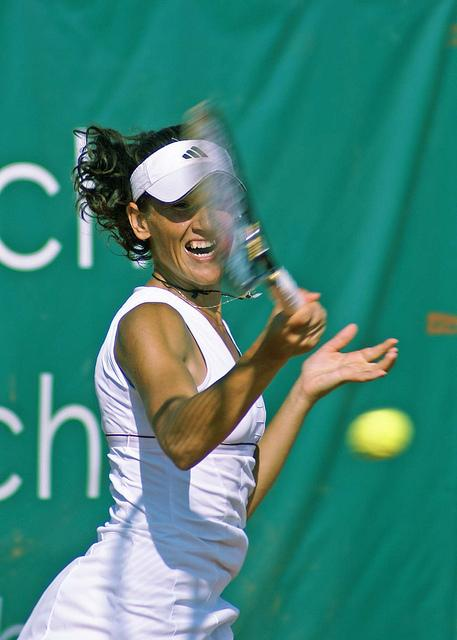Why is the racquet blurred?

Choices:
A) rapid motion
B) falling apart
C) dropping it
D) out focus rapid motion 